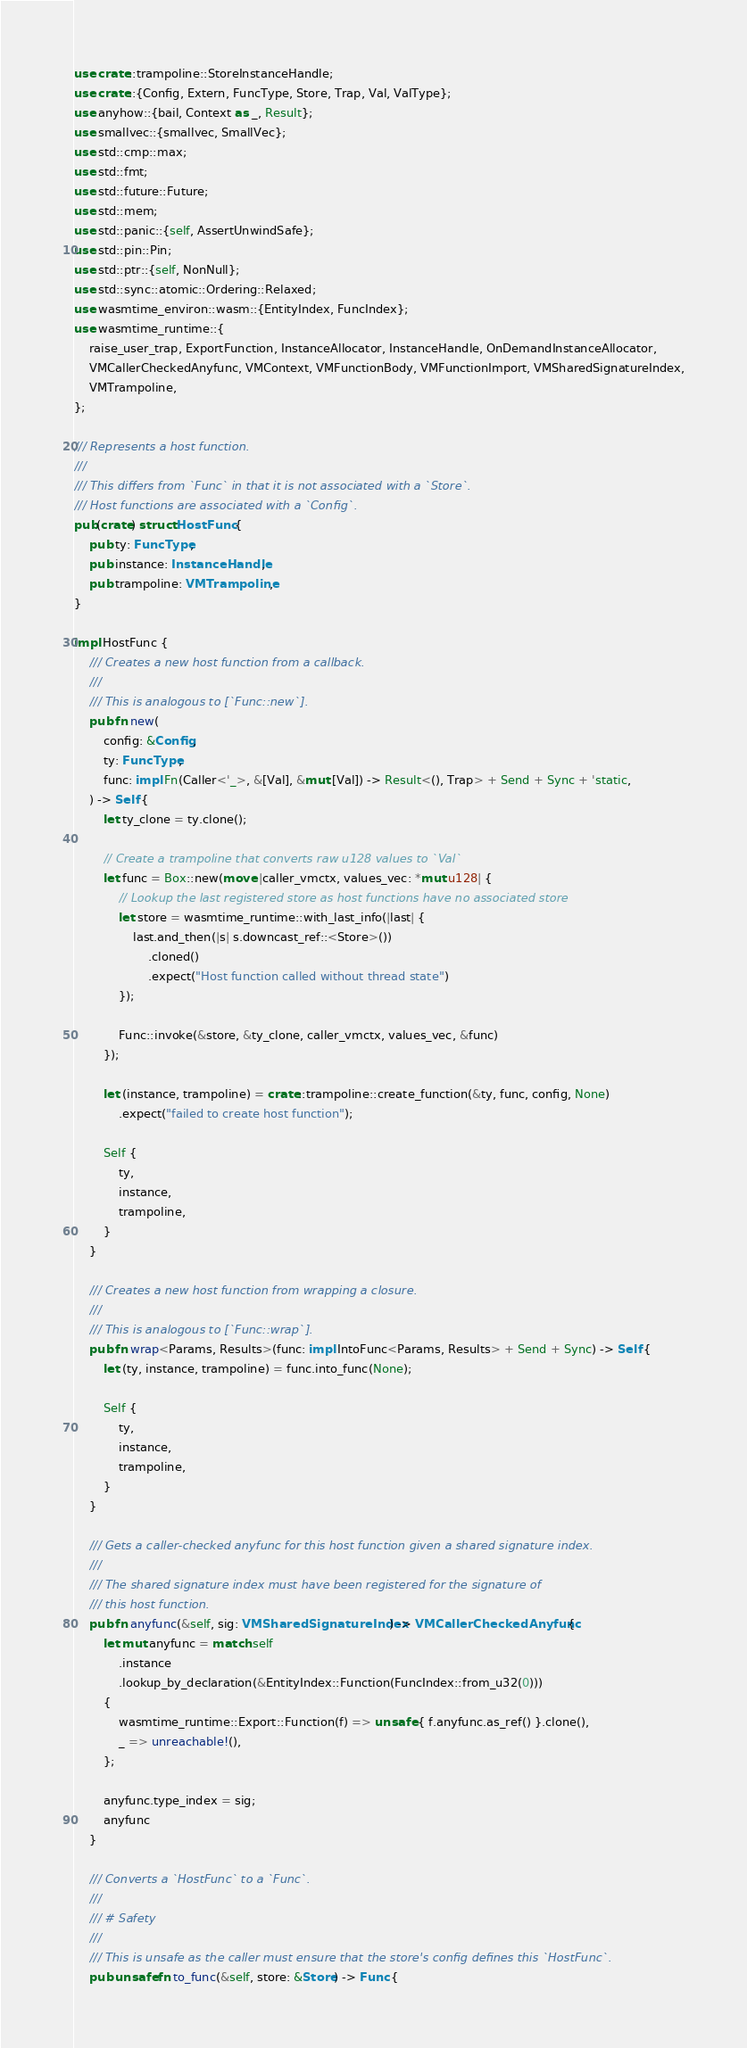<code> <loc_0><loc_0><loc_500><loc_500><_Rust_>use crate::trampoline::StoreInstanceHandle;
use crate::{Config, Extern, FuncType, Store, Trap, Val, ValType};
use anyhow::{bail, Context as _, Result};
use smallvec::{smallvec, SmallVec};
use std::cmp::max;
use std::fmt;
use std::future::Future;
use std::mem;
use std::panic::{self, AssertUnwindSafe};
use std::pin::Pin;
use std::ptr::{self, NonNull};
use std::sync::atomic::Ordering::Relaxed;
use wasmtime_environ::wasm::{EntityIndex, FuncIndex};
use wasmtime_runtime::{
    raise_user_trap, ExportFunction, InstanceAllocator, InstanceHandle, OnDemandInstanceAllocator,
    VMCallerCheckedAnyfunc, VMContext, VMFunctionBody, VMFunctionImport, VMSharedSignatureIndex,
    VMTrampoline,
};

/// Represents a host function.
///
/// This differs from `Func` in that it is not associated with a `Store`.
/// Host functions are associated with a `Config`.
pub(crate) struct HostFunc {
    pub ty: FuncType,
    pub instance: InstanceHandle,
    pub trampoline: VMTrampoline,
}

impl HostFunc {
    /// Creates a new host function from a callback.
    ///
    /// This is analogous to [`Func::new`].
    pub fn new(
        config: &Config,
        ty: FuncType,
        func: impl Fn(Caller<'_>, &[Val], &mut [Val]) -> Result<(), Trap> + Send + Sync + 'static,
    ) -> Self {
        let ty_clone = ty.clone();

        // Create a trampoline that converts raw u128 values to `Val`
        let func = Box::new(move |caller_vmctx, values_vec: *mut u128| {
            // Lookup the last registered store as host functions have no associated store
            let store = wasmtime_runtime::with_last_info(|last| {
                last.and_then(|s| s.downcast_ref::<Store>())
                    .cloned()
                    .expect("Host function called without thread state")
            });

            Func::invoke(&store, &ty_clone, caller_vmctx, values_vec, &func)
        });

        let (instance, trampoline) = crate::trampoline::create_function(&ty, func, config, None)
            .expect("failed to create host function");

        Self {
            ty,
            instance,
            trampoline,
        }
    }

    /// Creates a new host function from wrapping a closure.
    ///
    /// This is analogous to [`Func::wrap`].
    pub fn wrap<Params, Results>(func: impl IntoFunc<Params, Results> + Send + Sync) -> Self {
        let (ty, instance, trampoline) = func.into_func(None);

        Self {
            ty,
            instance,
            trampoline,
        }
    }

    /// Gets a caller-checked anyfunc for this host function given a shared signature index.
    ///
    /// The shared signature index must have been registered for the signature of
    /// this host function.
    pub fn anyfunc(&self, sig: VMSharedSignatureIndex) -> VMCallerCheckedAnyfunc {
        let mut anyfunc = match self
            .instance
            .lookup_by_declaration(&EntityIndex::Function(FuncIndex::from_u32(0)))
        {
            wasmtime_runtime::Export::Function(f) => unsafe { f.anyfunc.as_ref() }.clone(),
            _ => unreachable!(),
        };

        anyfunc.type_index = sig;
        anyfunc
    }

    /// Converts a `HostFunc` to a `Func`.
    ///
    /// # Safety
    ///
    /// This is unsafe as the caller must ensure that the store's config defines this `HostFunc`.
    pub unsafe fn to_func(&self, store: &Store) -> Func {</code> 